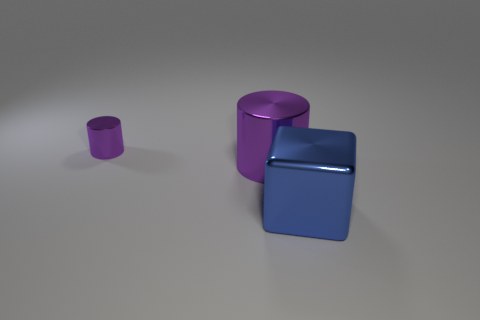What number of red rubber blocks are there?
Keep it short and to the point. 0. What is the shape of the object that is both on the left side of the blue metallic thing and right of the tiny cylinder?
Ensure brevity in your answer.  Cylinder. Does the thing that is behind the big purple shiny thing have the same color as the big metallic thing that is behind the blue object?
Keep it short and to the point. Yes. There is a object that is the same color as the tiny shiny cylinder; what size is it?
Make the answer very short. Large. Is there another blue object that has the same material as the big blue object?
Keep it short and to the point. No. Are there an equal number of purple metallic cylinders that are behind the tiny purple metal cylinder and big cylinders in front of the blue object?
Provide a succinct answer. Yes. How big is the blue object that is to the right of the big cylinder?
Your answer should be very brief. Large. What material is the purple object that is behind the large metallic object that is on the left side of the blue metallic cube made of?
Give a very brief answer. Metal. How many big blocks are left of the thing behind the big metallic thing that is behind the big blue shiny object?
Ensure brevity in your answer.  0. Is the purple thing that is on the right side of the tiny purple cylinder made of the same material as the object that is to the right of the big metal cylinder?
Provide a succinct answer. Yes. 